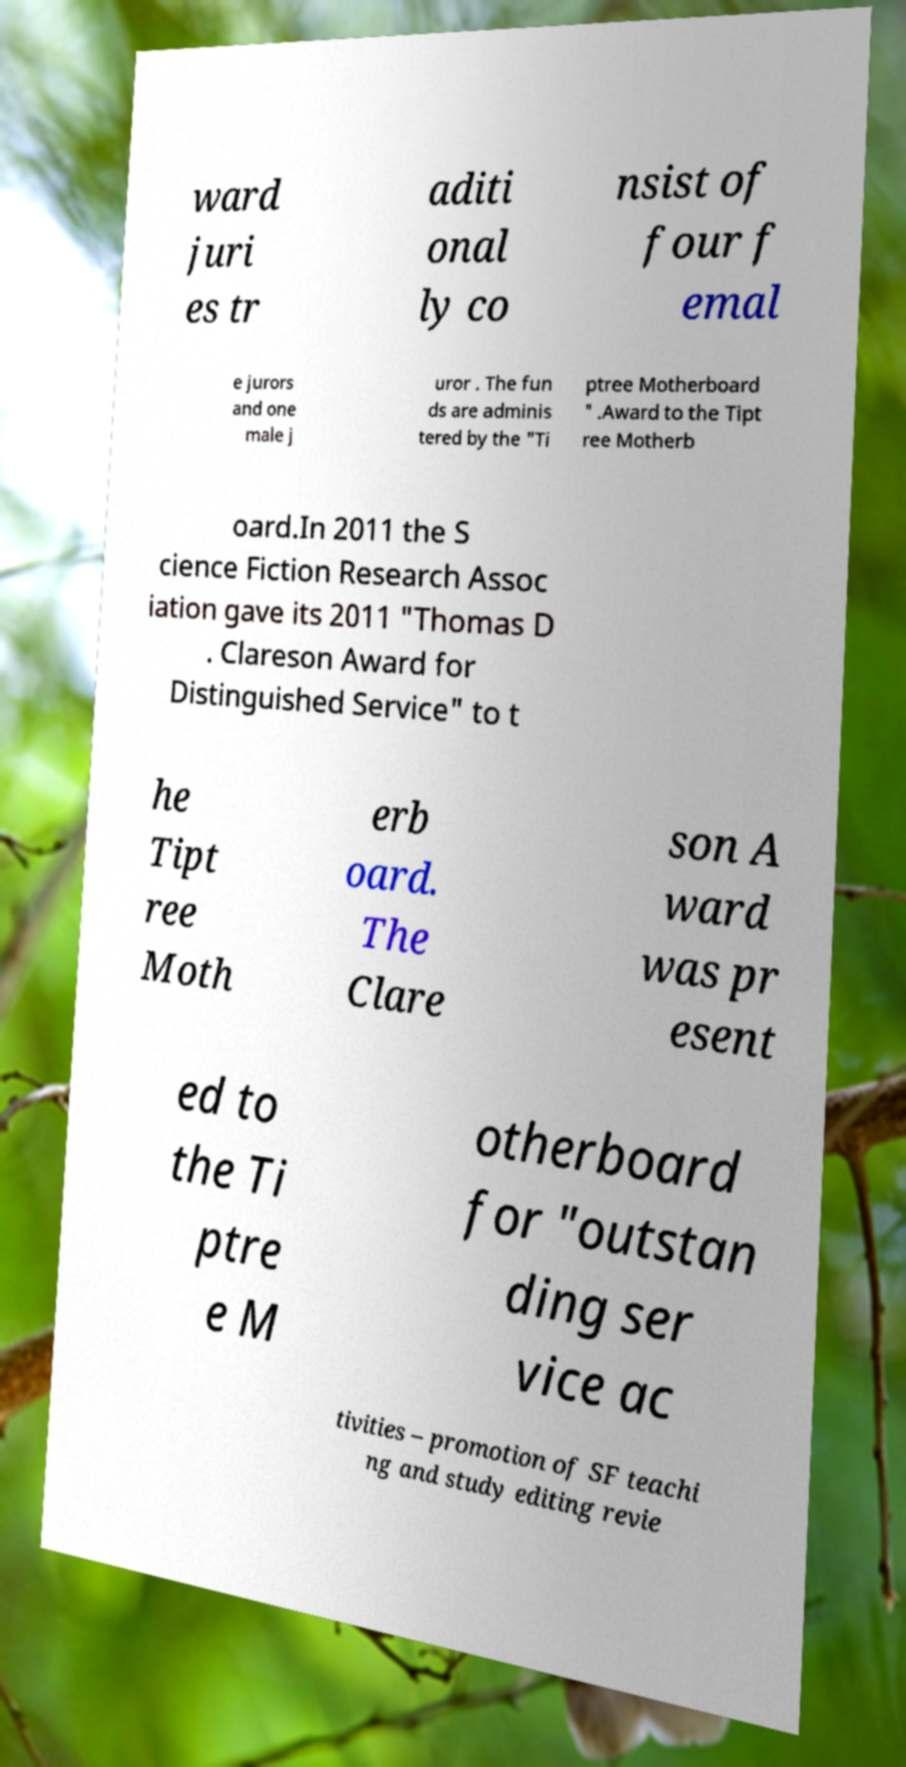Please identify and transcribe the text found in this image. ward juri es tr aditi onal ly co nsist of four f emal e jurors and one male j uror . The fun ds are adminis tered by the "Ti ptree Motherboard " .Award to the Tipt ree Motherb oard.In 2011 the S cience Fiction Research Assoc iation gave its 2011 "Thomas D . Clareson Award for Distinguished Service" to t he Tipt ree Moth erb oard. The Clare son A ward was pr esent ed to the Ti ptre e M otherboard for "outstan ding ser vice ac tivities – promotion of SF teachi ng and study editing revie 